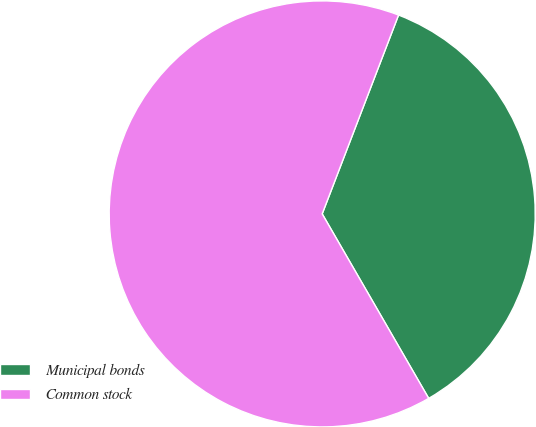Convert chart to OTSL. <chart><loc_0><loc_0><loc_500><loc_500><pie_chart><fcel>Municipal bonds<fcel>Common stock<nl><fcel>35.83%<fcel>64.17%<nl></chart> 